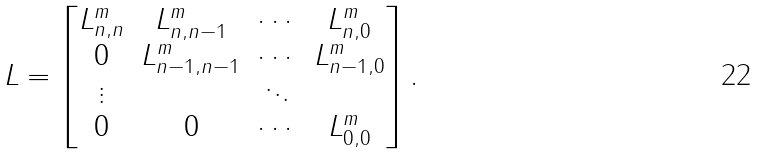<formula> <loc_0><loc_0><loc_500><loc_500>L = \left [ \begin{matrix} L ^ { m } _ { n , n } & L ^ { m } _ { n , n - 1 } & \cdots & L ^ { m } _ { n , 0 } \\ 0 & L ^ { m } _ { n - 1 , n - 1 } & \cdots & L ^ { m } _ { n - 1 , 0 } \\ \vdots & & \ddots \\ 0 & 0 & \cdots & L ^ { m } _ { 0 , 0 } \end{matrix} \right ] .</formula> 